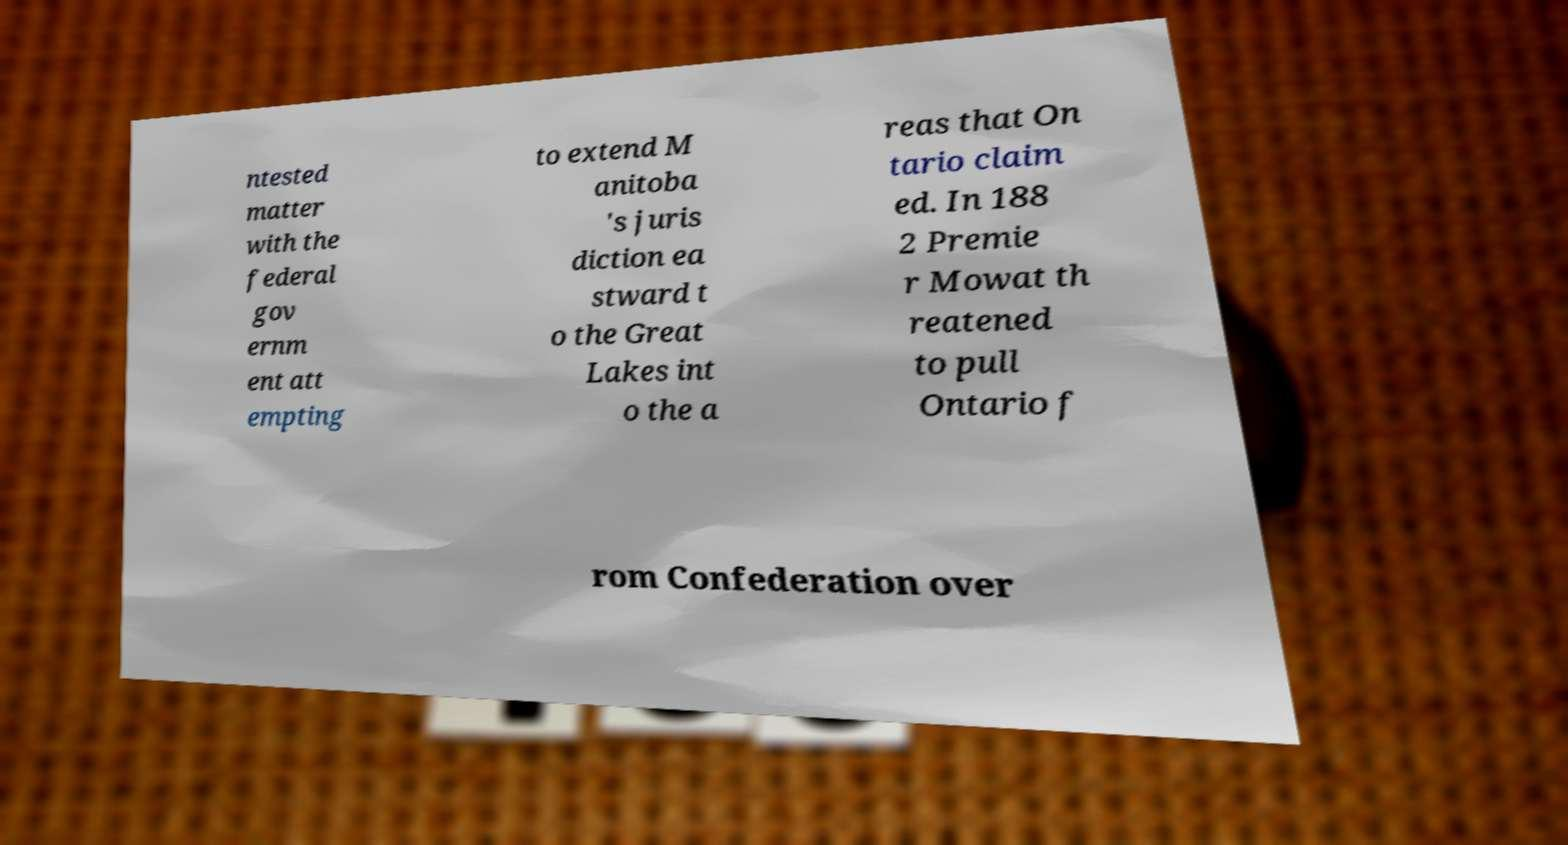There's text embedded in this image that I need extracted. Can you transcribe it verbatim? ntested matter with the federal gov ernm ent att empting to extend M anitoba 's juris diction ea stward t o the Great Lakes int o the a reas that On tario claim ed. In 188 2 Premie r Mowat th reatened to pull Ontario f rom Confederation over 